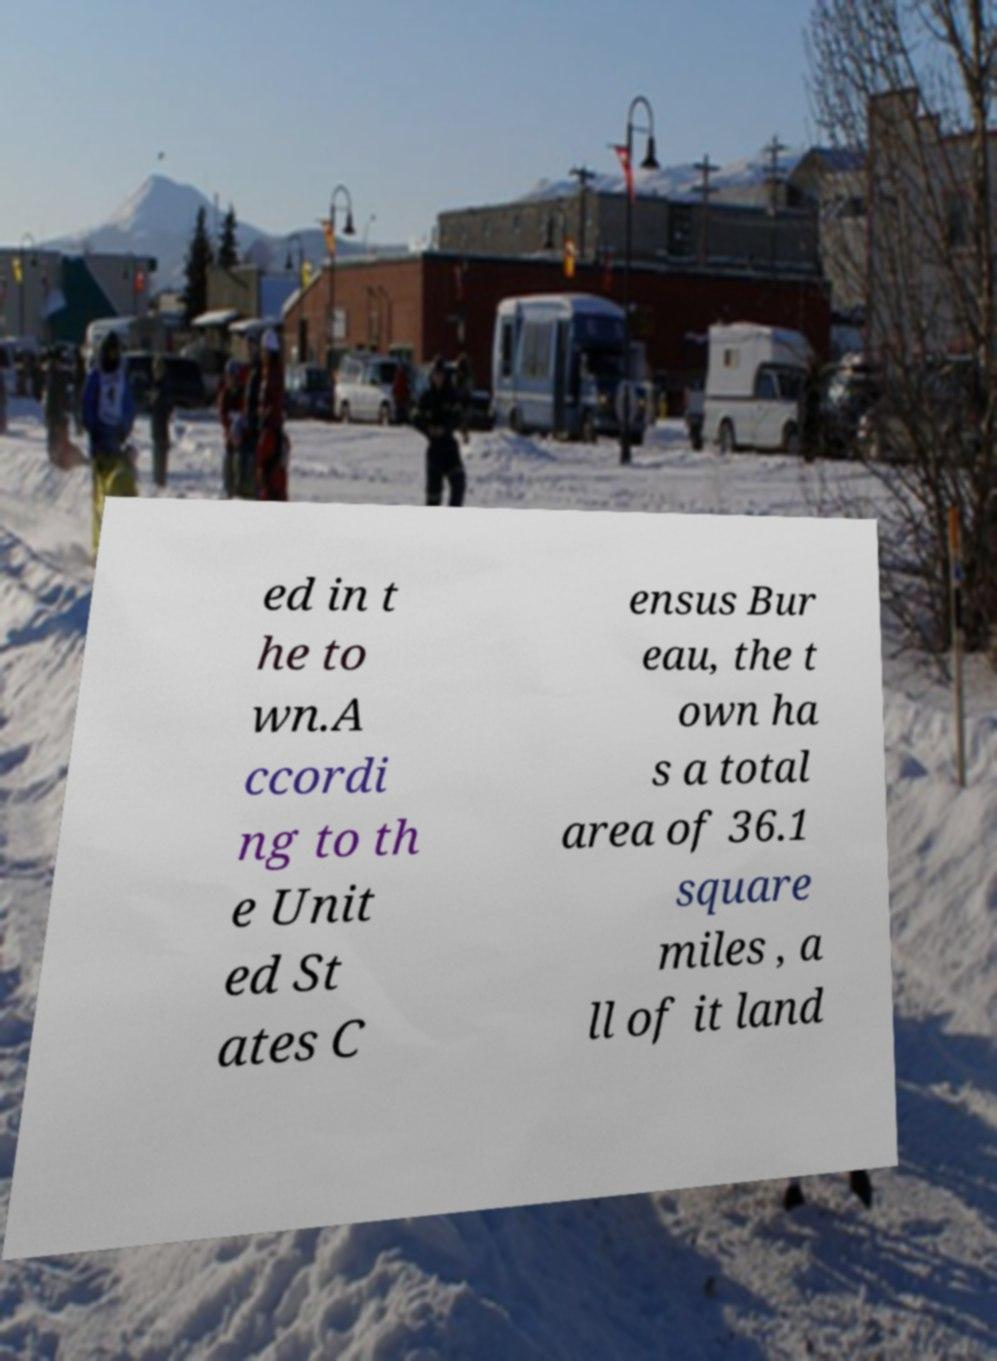Could you extract and type out the text from this image? ed in t he to wn.A ccordi ng to th e Unit ed St ates C ensus Bur eau, the t own ha s a total area of 36.1 square miles , a ll of it land 